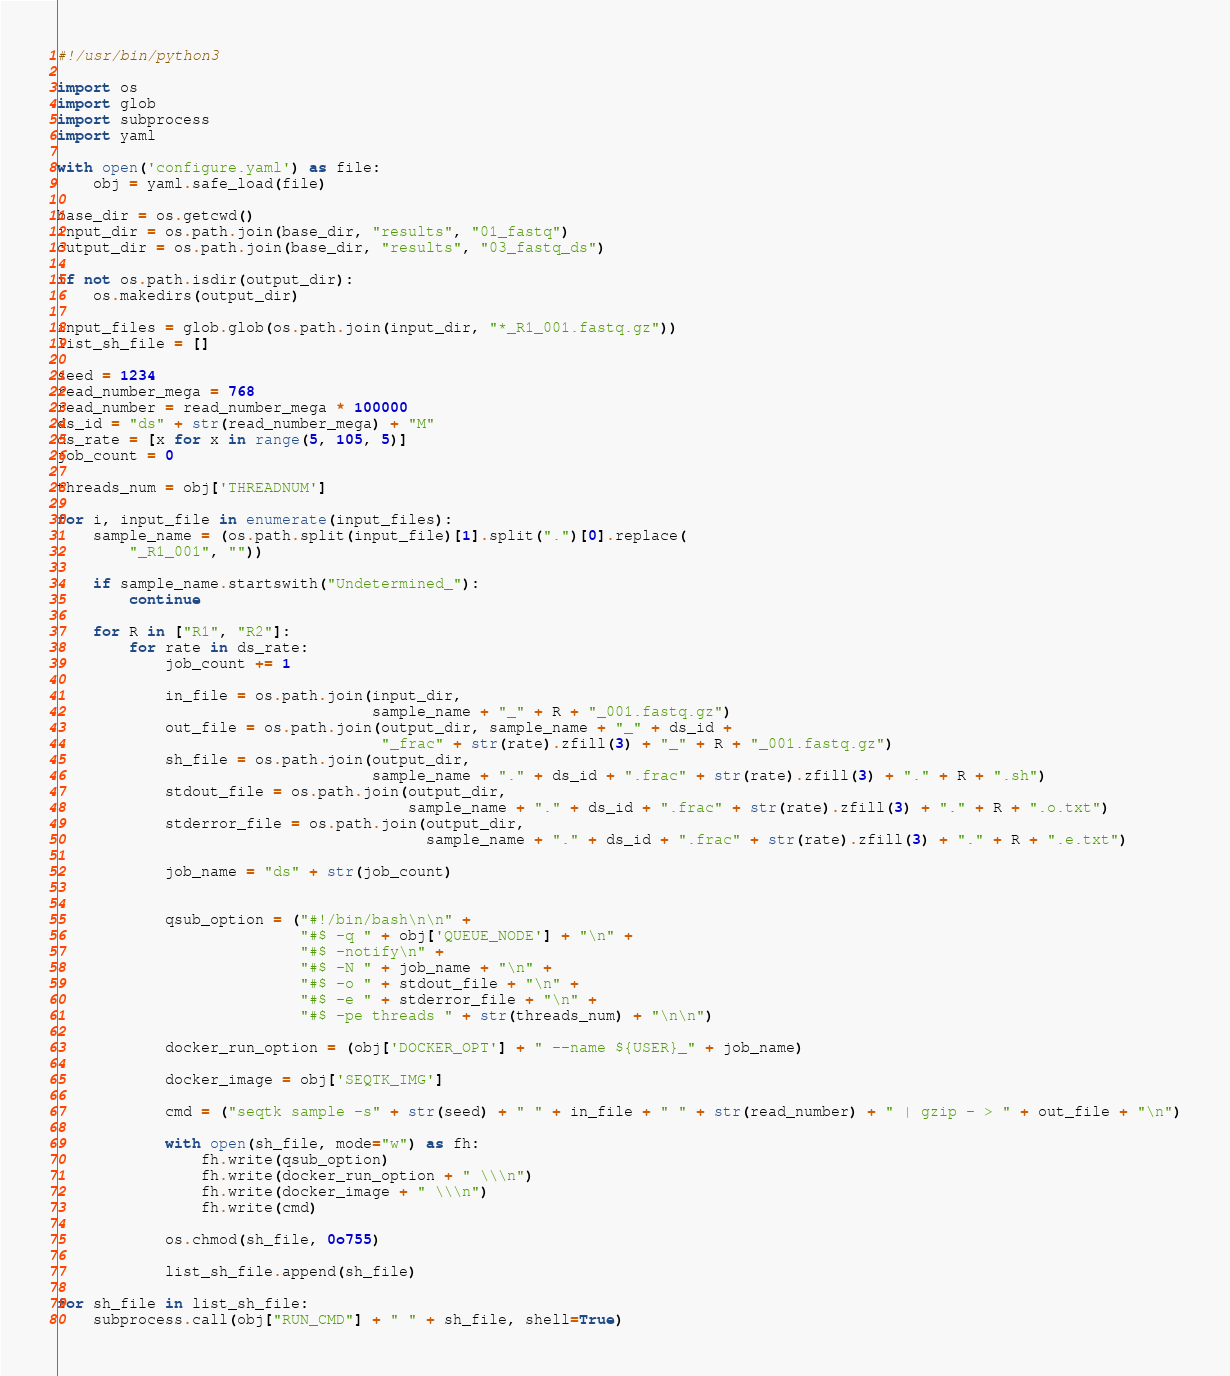Convert code to text. <code><loc_0><loc_0><loc_500><loc_500><_Python_>#!/usr/bin/python3

import os
import glob
import subprocess
import yaml

with open('configure.yaml') as file:
    obj = yaml.safe_load(file)

base_dir = os.getcwd()
input_dir = os.path.join(base_dir, "results", "01_fastq")
output_dir = os.path.join(base_dir, "results", "03_fastq_ds")

if not os.path.isdir(output_dir):
    os.makedirs(output_dir)

input_files = glob.glob(os.path.join(input_dir, "*_R1_001.fastq.gz"))
list_sh_file = []

seed = 1234
read_number_mega = 768
read_number = read_number_mega * 100000
ds_id = "ds" + str(read_number_mega) + "M"
ds_rate = [x for x in range(5, 105, 5)]
job_count = 0

threads_num = obj['THREADNUM']

for i, input_file in enumerate(input_files):
    sample_name = (os.path.split(input_file)[1].split(".")[0].replace(
        "_R1_001", ""))

    if sample_name.startswith("Undetermined_"):
        continue

    for R in ["R1", "R2"]:
        for rate in ds_rate:
            job_count += 1

            in_file = os.path.join(input_dir,
                                   sample_name + "_" + R + "_001.fastq.gz")
            out_file = os.path.join(output_dir, sample_name + "_" + ds_id +
                                    "_frac" + str(rate).zfill(3) + "_" + R + "_001.fastq.gz")
            sh_file = os.path.join(output_dir,
                                   sample_name + "." + ds_id + ".frac" + str(rate).zfill(3) + "." + R + ".sh")
            stdout_file = os.path.join(output_dir,
                                       sample_name + "." + ds_id + ".frac" + str(rate).zfill(3) + "." + R + ".o.txt")
            stderror_file = os.path.join(output_dir,
                                         sample_name + "." + ds_id + ".frac" + str(rate).zfill(3) + "." + R + ".e.txt")

            job_name = "ds" + str(job_count)


            qsub_option = ("#!/bin/bash\n\n" +
                           "#$ -q " + obj['QUEUE_NODE'] + "\n" +
                           "#$ -notify\n" +
                           "#$ -N " + job_name + "\n" +
                           "#$ -o " + stdout_file + "\n" +
                           "#$ -e " + stderror_file + "\n" +
                           "#$ -pe threads " + str(threads_num) + "\n\n")

            docker_run_option = (obj['DOCKER_OPT'] + " --name ${USER}_" + job_name)

            docker_image = obj['SEQTK_IMG']

            cmd = ("seqtk sample -s" + str(seed) + " " + in_file + " " + str(read_number) + " | gzip - > " + out_file + "\n")

            with open(sh_file, mode="w") as fh:
                fh.write(qsub_option)
                fh.write(docker_run_option + " \\\n")
                fh.write(docker_image + " \\\n")
                fh.write(cmd)

            os.chmod(sh_file, 0o755)

            list_sh_file.append(sh_file)

for sh_file in list_sh_file:
    subprocess.call(obj["RUN_CMD"] + " " + sh_file, shell=True)
</code> 